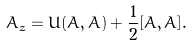Convert formula to latex. <formula><loc_0><loc_0><loc_500><loc_500>A _ { \bar { z } } = U ( A , \bar { A } ) + \frac { 1 } { 2 } [ A , \bar { A } ] .</formula> 